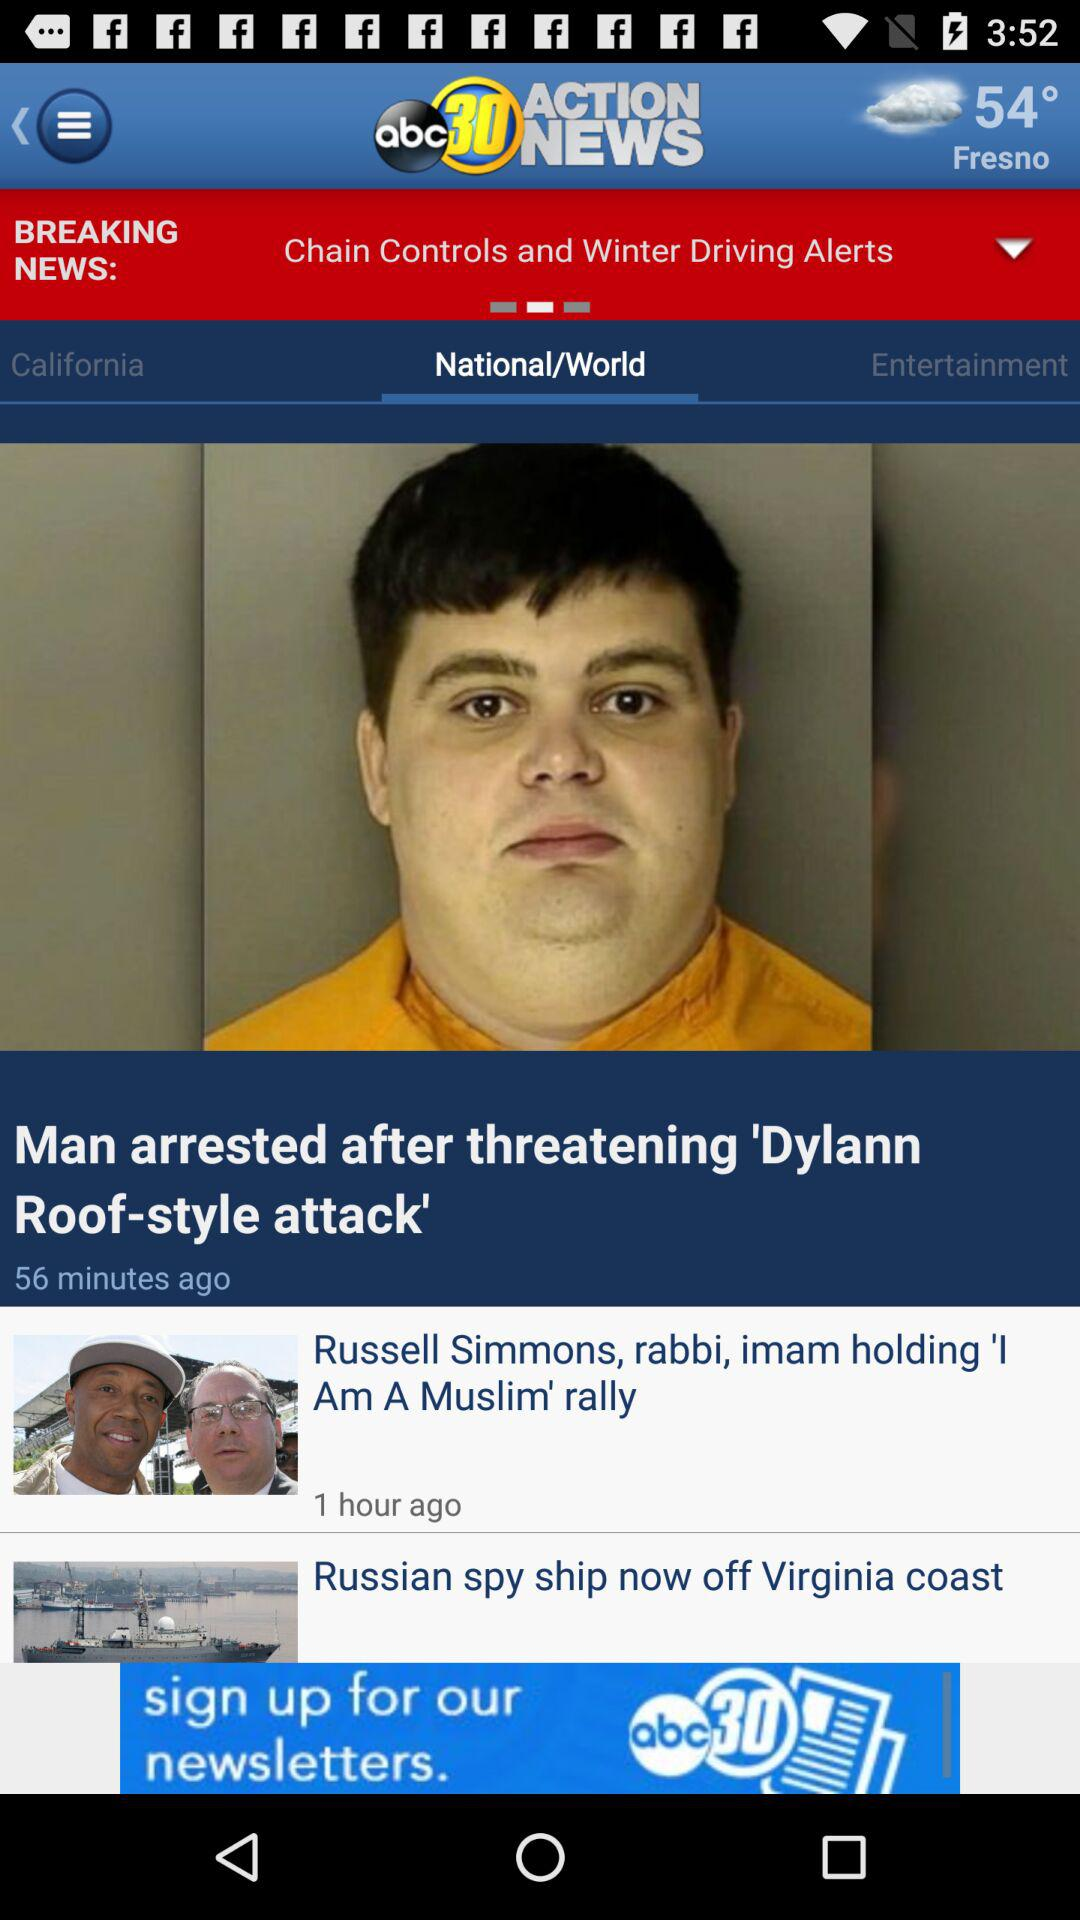What is the temperature shown? The temperature shown is 54°. 